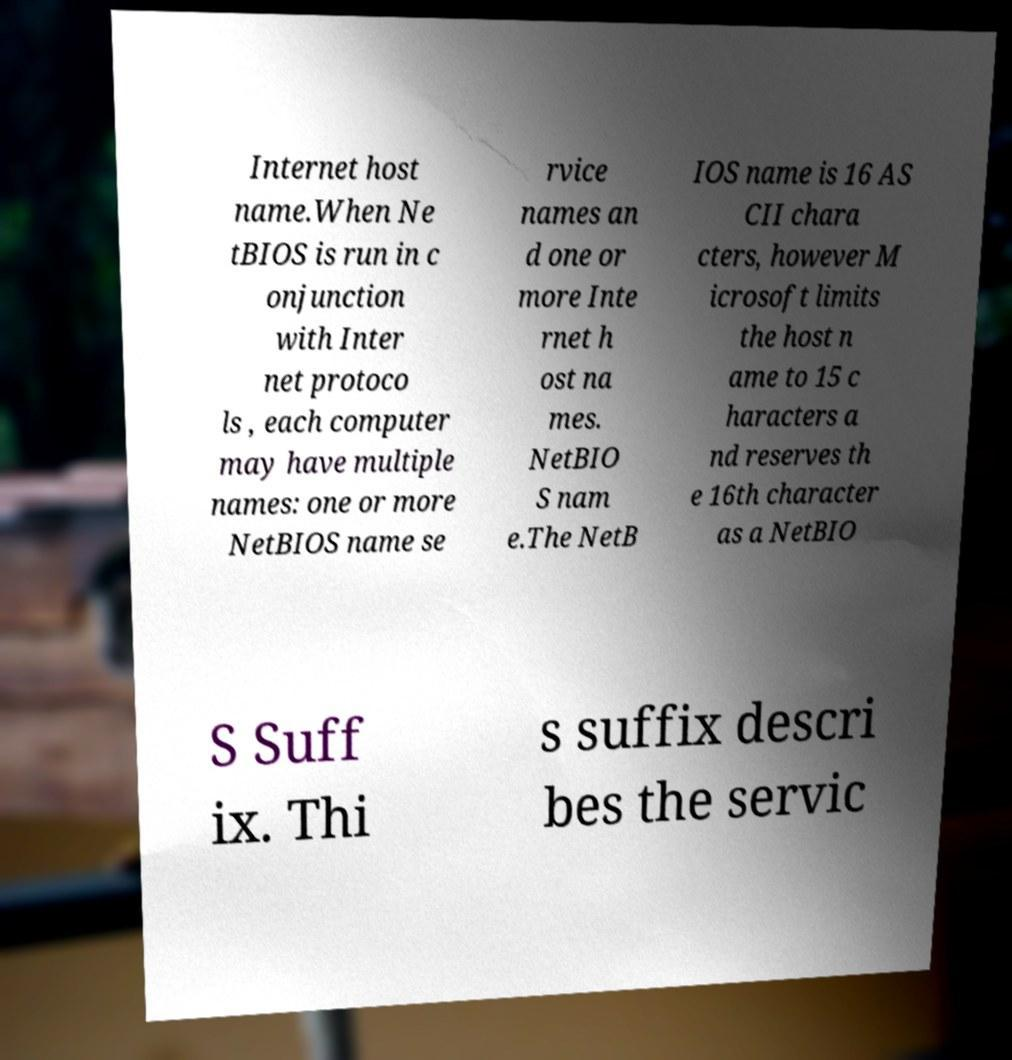Could you extract and type out the text from this image? Internet host name.When Ne tBIOS is run in c onjunction with Inter net protoco ls , each computer may have multiple names: one or more NetBIOS name se rvice names an d one or more Inte rnet h ost na mes. NetBIO S nam e.The NetB IOS name is 16 AS CII chara cters, however M icrosoft limits the host n ame to 15 c haracters a nd reserves th e 16th character as a NetBIO S Suff ix. Thi s suffix descri bes the servic 